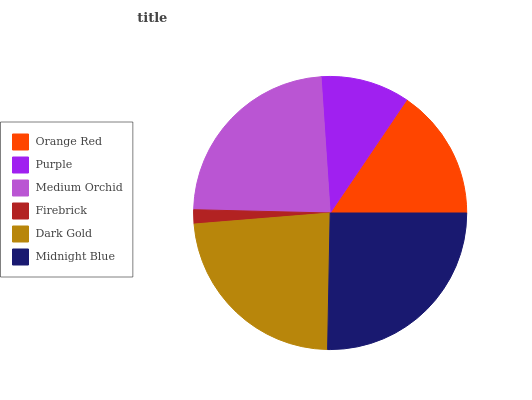Is Firebrick the minimum?
Answer yes or no. Yes. Is Midnight Blue the maximum?
Answer yes or no. Yes. Is Purple the minimum?
Answer yes or no. No. Is Purple the maximum?
Answer yes or no. No. Is Orange Red greater than Purple?
Answer yes or no. Yes. Is Purple less than Orange Red?
Answer yes or no. Yes. Is Purple greater than Orange Red?
Answer yes or no. No. Is Orange Red less than Purple?
Answer yes or no. No. Is Dark Gold the high median?
Answer yes or no. Yes. Is Orange Red the low median?
Answer yes or no. Yes. Is Firebrick the high median?
Answer yes or no. No. Is Midnight Blue the low median?
Answer yes or no. No. 